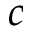<formula> <loc_0><loc_0><loc_500><loc_500>c</formula> 